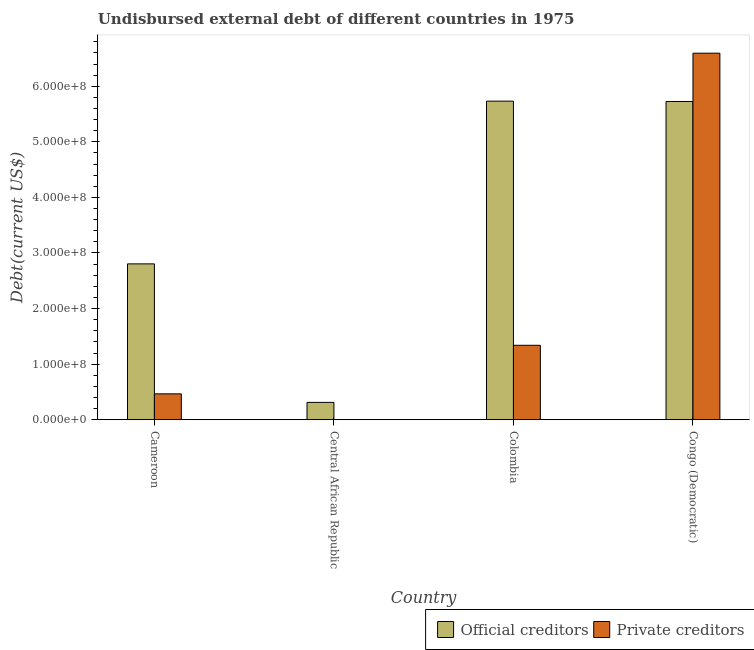How many different coloured bars are there?
Keep it short and to the point. 2. How many bars are there on the 1st tick from the right?
Provide a succinct answer. 2. What is the label of the 4th group of bars from the left?
Ensure brevity in your answer.  Congo (Democratic). In how many cases, is the number of bars for a given country not equal to the number of legend labels?
Make the answer very short. 0. What is the undisbursed external debt of official creditors in Central African Republic?
Your response must be concise. 3.12e+07. Across all countries, what is the maximum undisbursed external debt of official creditors?
Your response must be concise. 5.73e+08. Across all countries, what is the minimum undisbursed external debt of official creditors?
Keep it short and to the point. 3.12e+07. In which country was the undisbursed external debt of private creditors minimum?
Your answer should be very brief. Central African Republic. What is the total undisbursed external debt of private creditors in the graph?
Provide a succinct answer. 8.40e+08. What is the difference between the undisbursed external debt of private creditors in Cameroon and that in Colombia?
Make the answer very short. -8.74e+07. What is the difference between the undisbursed external debt of private creditors in Central African Republic and the undisbursed external debt of official creditors in Colombia?
Your response must be concise. -5.73e+08. What is the average undisbursed external debt of official creditors per country?
Give a very brief answer. 3.64e+08. What is the difference between the undisbursed external debt of official creditors and undisbursed external debt of private creditors in Congo (Democratic)?
Make the answer very short. -8.69e+07. What is the ratio of the undisbursed external debt of official creditors in Colombia to that in Congo (Democratic)?
Offer a terse response. 1. Is the difference between the undisbursed external debt of official creditors in Cameroon and Congo (Democratic) greater than the difference between the undisbursed external debt of private creditors in Cameroon and Congo (Democratic)?
Give a very brief answer. Yes. What is the difference between the highest and the second highest undisbursed external debt of private creditors?
Keep it short and to the point. 5.26e+08. What is the difference between the highest and the lowest undisbursed external debt of private creditors?
Ensure brevity in your answer.  6.59e+08. In how many countries, is the undisbursed external debt of official creditors greater than the average undisbursed external debt of official creditors taken over all countries?
Your response must be concise. 2. What does the 1st bar from the left in Central African Republic represents?
Provide a succinct answer. Official creditors. What does the 1st bar from the right in Central African Republic represents?
Ensure brevity in your answer.  Private creditors. How many countries are there in the graph?
Ensure brevity in your answer.  4. What is the difference between two consecutive major ticks on the Y-axis?
Your response must be concise. 1.00e+08. How are the legend labels stacked?
Offer a terse response. Horizontal. What is the title of the graph?
Keep it short and to the point. Undisbursed external debt of different countries in 1975. Does "GDP per capita" appear as one of the legend labels in the graph?
Make the answer very short. No. What is the label or title of the Y-axis?
Your response must be concise. Debt(current US$). What is the Debt(current US$) of Official creditors in Cameroon?
Offer a very short reply. 2.80e+08. What is the Debt(current US$) of Private creditors in Cameroon?
Offer a terse response. 4.65e+07. What is the Debt(current US$) of Official creditors in Central African Republic?
Your answer should be very brief. 3.12e+07. What is the Debt(current US$) of Private creditors in Central African Republic?
Provide a succinct answer. 1.62e+05. What is the Debt(current US$) in Official creditors in Colombia?
Provide a short and direct response. 5.73e+08. What is the Debt(current US$) of Private creditors in Colombia?
Offer a very short reply. 1.34e+08. What is the Debt(current US$) of Official creditors in Congo (Democratic)?
Offer a very short reply. 5.73e+08. What is the Debt(current US$) of Private creditors in Congo (Democratic)?
Give a very brief answer. 6.59e+08. Across all countries, what is the maximum Debt(current US$) of Official creditors?
Offer a terse response. 5.73e+08. Across all countries, what is the maximum Debt(current US$) of Private creditors?
Give a very brief answer. 6.59e+08. Across all countries, what is the minimum Debt(current US$) in Official creditors?
Offer a very short reply. 3.12e+07. Across all countries, what is the minimum Debt(current US$) of Private creditors?
Your answer should be very brief. 1.62e+05. What is the total Debt(current US$) in Official creditors in the graph?
Offer a very short reply. 1.46e+09. What is the total Debt(current US$) of Private creditors in the graph?
Your response must be concise. 8.40e+08. What is the difference between the Debt(current US$) in Official creditors in Cameroon and that in Central African Republic?
Offer a very short reply. 2.49e+08. What is the difference between the Debt(current US$) of Private creditors in Cameroon and that in Central African Republic?
Give a very brief answer. 4.63e+07. What is the difference between the Debt(current US$) in Official creditors in Cameroon and that in Colombia?
Your response must be concise. -2.93e+08. What is the difference between the Debt(current US$) of Private creditors in Cameroon and that in Colombia?
Your response must be concise. -8.74e+07. What is the difference between the Debt(current US$) in Official creditors in Cameroon and that in Congo (Democratic)?
Make the answer very short. -2.92e+08. What is the difference between the Debt(current US$) of Private creditors in Cameroon and that in Congo (Democratic)?
Provide a short and direct response. -6.13e+08. What is the difference between the Debt(current US$) of Official creditors in Central African Republic and that in Colombia?
Your answer should be compact. -5.42e+08. What is the difference between the Debt(current US$) of Private creditors in Central African Republic and that in Colombia?
Make the answer very short. -1.34e+08. What is the difference between the Debt(current US$) of Official creditors in Central African Republic and that in Congo (Democratic)?
Give a very brief answer. -5.41e+08. What is the difference between the Debt(current US$) in Private creditors in Central African Republic and that in Congo (Democratic)?
Ensure brevity in your answer.  -6.59e+08. What is the difference between the Debt(current US$) in Official creditors in Colombia and that in Congo (Democratic)?
Make the answer very short. 5.97e+05. What is the difference between the Debt(current US$) in Private creditors in Colombia and that in Congo (Democratic)?
Your response must be concise. -5.26e+08. What is the difference between the Debt(current US$) of Official creditors in Cameroon and the Debt(current US$) of Private creditors in Central African Republic?
Make the answer very short. 2.80e+08. What is the difference between the Debt(current US$) of Official creditors in Cameroon and the Debt(current US$) of Private creditors in Colombia?
Ensure brevity in your answer.  1.47e+08. What is the difference between the Debt(current US$) of Official creditors in Cameroon and the Debt(current US$) of Private creditors in Congo (Democratic)?
Keep it short and to the point. -3.79e+08. What is the difference between the Debt(current US$) in Official creditors in Central African Republic and the Debt(current US$) in Private creditors in Colombia?
Give a very brief answer. -1.03e+08. What is the difference between the Debt(current US$) of Official creditors in Central African Republic and the Debt(current US$) of Private creditors in Congo (Democratic)?
Your answer should be very brief. -6.28e+08. What is the difference between the Debt(current US$) in Official creditors in Colombia and the Debt(current US$) in Private creditors in Congo (Democratic)?
Keep it short and to the point. -8.63e+07. What is the average Debt(current US$) in Official creditors per country?
Offer a terse response. 3.64e+08. What is the average Debt(current US$) of Private creditors per country?
Make the answer very short. 2.10e+08. What is the difference between the Debt(current US$) in Official creditors and Debt(current US$) in Private creditors in Cameroon?
Provide a short and direct response. 2.34e+08. What is the difference between the Debt(current US$) of Official creditors and Debt(current US$) of Private creditors in Central African Republic?
Offer a very short reply. 3.10e+07. What is the difference between the Debt(current US$) in Official creditors and Debt(current US$) in Private creditors in Colombia?
Give a very brief answer. 4.39e+08. What is the difference between the Debt(current US$) of Official creditors and Debt(current US$) of Private creditors in Congo (Democratic)?
Your response must be concise. -8.69e+07. What is the ratio of the Debt(current US$) of Official creditors in Cameroon to that in Central African Republic?
Keep it short and to the point. 9. What is the ratio of the Debt(current US$) of Private creditors in Cameroon to that in Central African Republic?
Provide a succinct answer. 287.06. What is the ratio of the Debt(current US$) in Official creditors in Cameroon to that in Colombia?
Give a very brief answer. 0.49. What is the ratio of the Debt(current US$) in Private creditors in Cameroon to that in Colombia?
Your answer should be compact. 0.35. What is the ratio of the Debt(current US$) in Official creditors in Cameroon to that in Congo (Democratic)?
Your response must be concise. 0.49. What is the ratio of the Debt(current US$) in Private creditors in Cameroon to that in Congo (Democratic)?
Offer a terse response. 0.07. What is the ratio of the Debt(current US$) of Official creditors in Central African Republic to that in Colombia?
Provide a succinct answer. 0.05. What is the ratio of the Debt(current US$) in Private creditors in Central African Republic to that in Colombia?
Your response must be concise. 0. What is the ratio of the Debt(current US$) of Official creditors in Central African Republic to that in Congo (Democratic)?
Your answer should be very brief. 0.05. What is the ratio of the Debt(current US$) in Private creditors in Colombia to that in Congo (Democratic)?
Your answer should be very brief. 0.2. What is the difference between the highest and the second highest Debt(current US$) in Official creditors?
Offer a terse response. 5.97e+05. What is the difference between the highest and the second highest Debt(current US$) in Private creditors?
Give a very brief answer. 5.26e+08. What is the difference between the highest and the lowest Debt(current US$) of Official creditors?
Your response must be concise. 5.42e+08. What is the difference between the highest and the lowest Debt(current US$) in Private creditors?
Your response must be concise. 6.59e+08. 